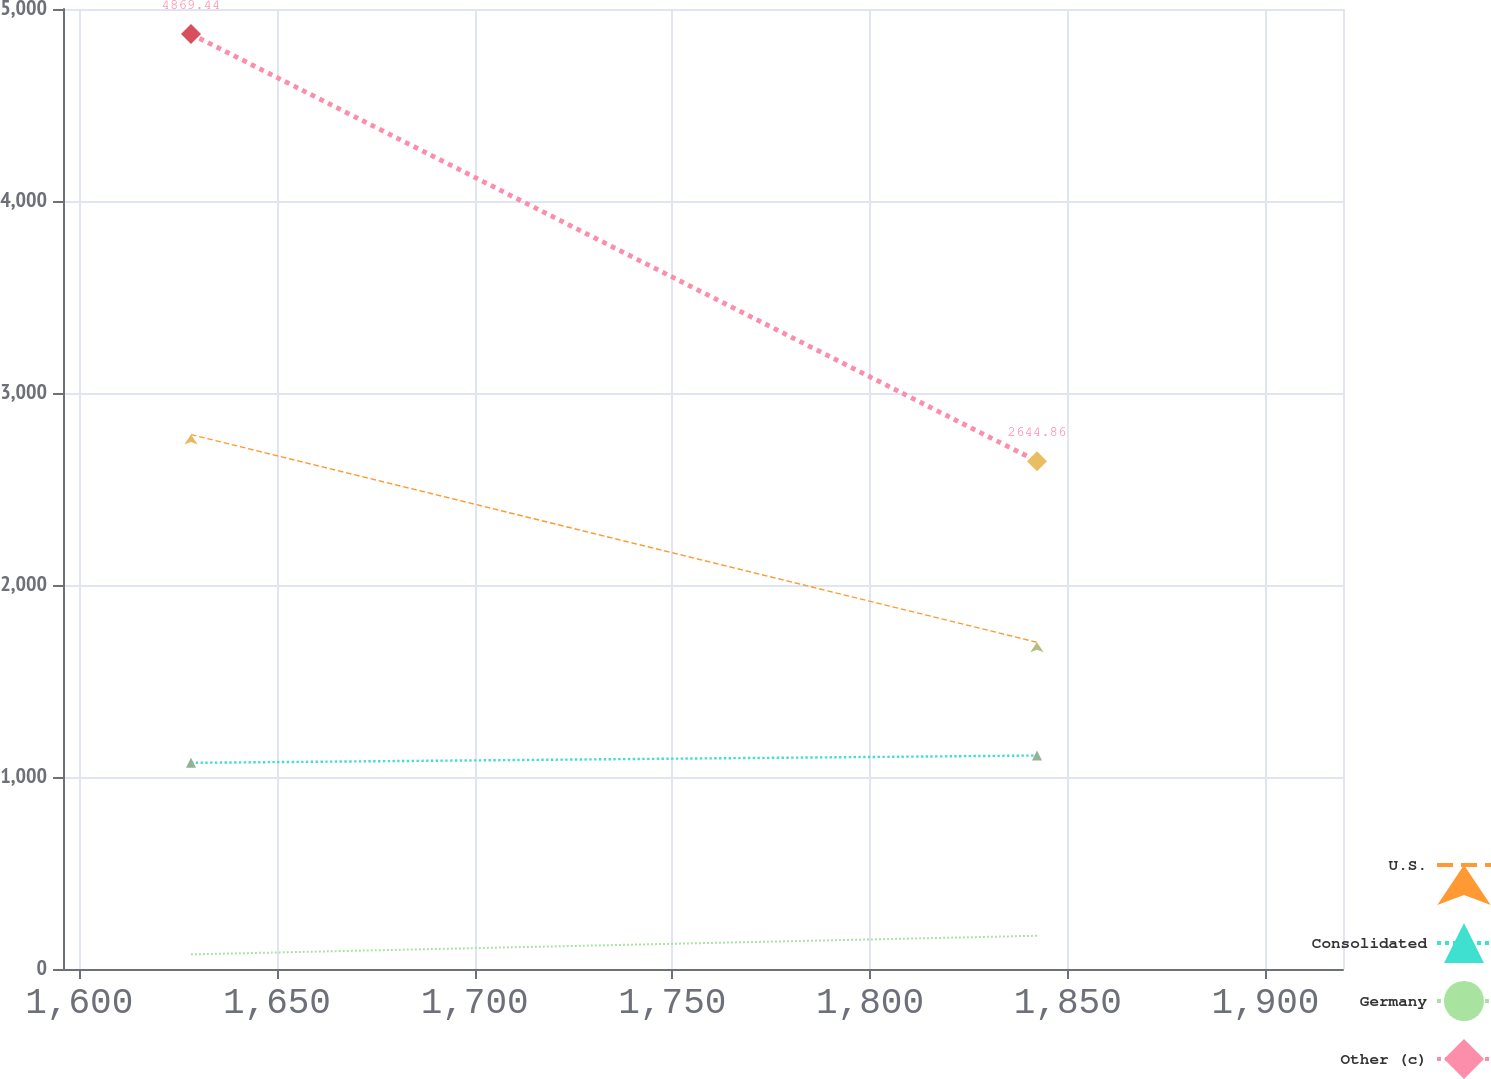Convert chart. <chart><loc_0><loc_0><loc_500><loc_500><line_chart><ecel><fcel>U.S.<fcel>Consolidated<fcel>Germany<fcel>Other (c)<nl><fcel>1628.26<fcel>2783.37<fcel>1073.82<fcel>76.26<fcel>4869.44<nl><fcel>1842.22<fcel>1701.67<fcel>1111.77<fcel>173.07<fcel>2644.86<nl><fcel>1951.99<fcel>2062.57<fcel>1453.33<fcel>124.99<fcel>3608.43<nl></chart> 